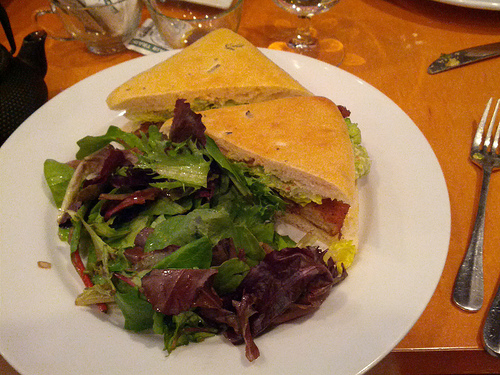Is the fork to the left or to the right of the sandwich? The fork is placed to the right of the sandwich, directly adjacent to it. 